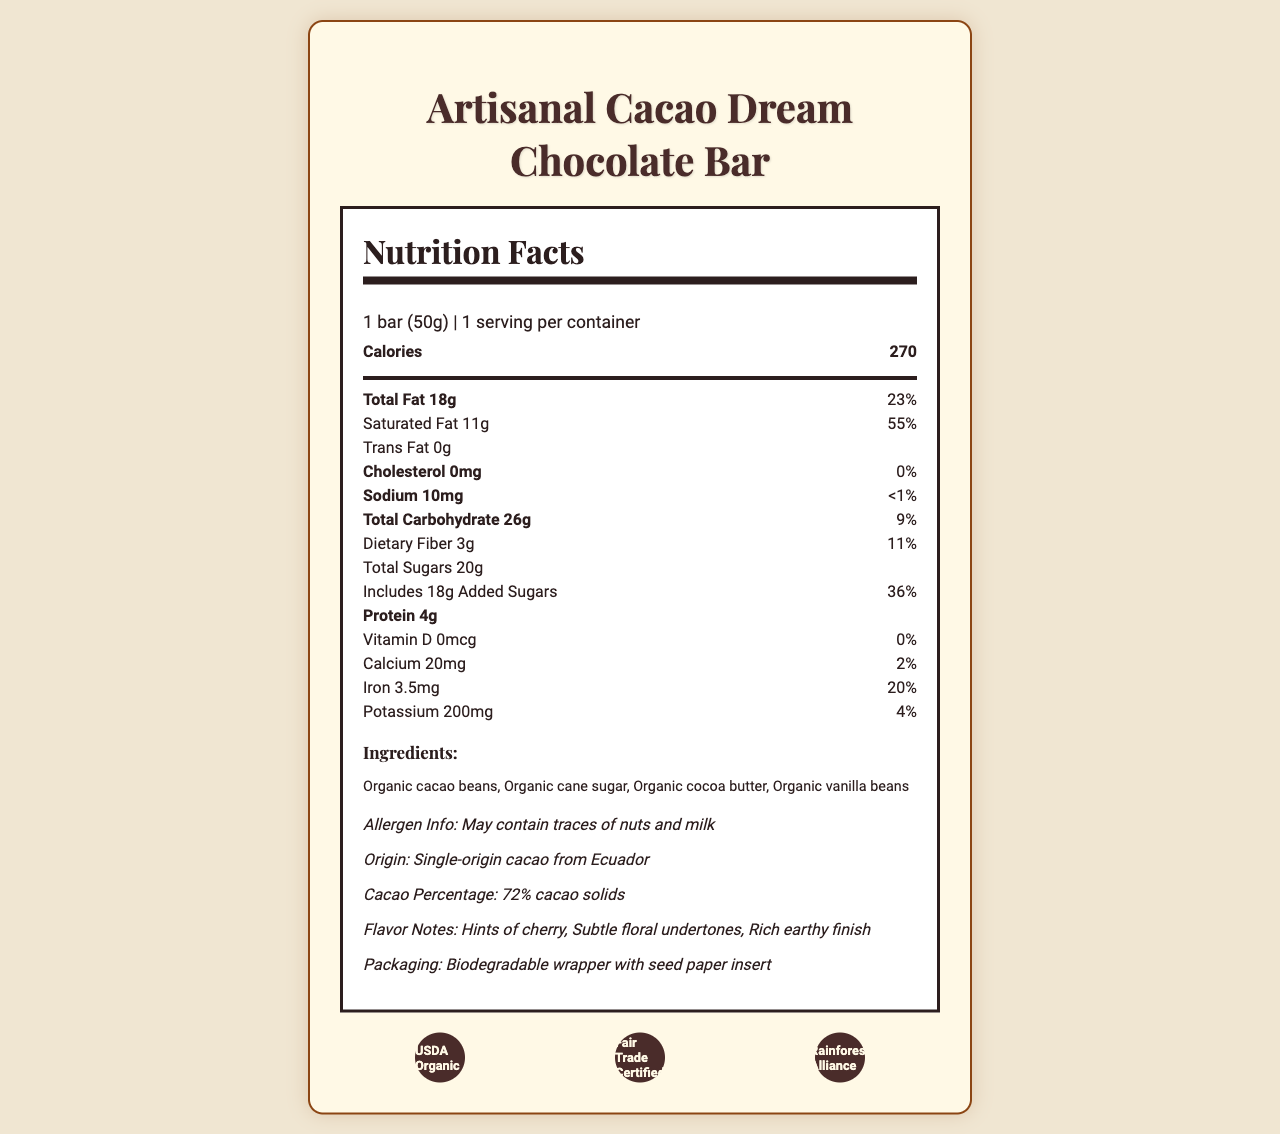what is the serving size of the Artisanal Cacao Dream Chocolate Bar? The serving size is explicitly mentioned as "1 bar (50g)" on the nutrition facts label.
Answer: 1 bar (50g) how many calories are in one serving? The document clearly states "Calories 270" under the nutrition details.
Answer: 270 list four key ingredients in the chocolate bar. The ingredients listed are: "Organic cacao beans, Organic cane sugar, Organic cocoa butter, Organic vanilla beans".
Answer: Organic cacao beans, Organic cane sugar, Organic cocoa butter, Organic vanilla beans what is the percentage of daily value for saturated fat? The document shows "Saturated Fat 11g 55%" in the nutritional facts.
Answer: 55% how much calcium does the chocolate bar contain? The amount of calcium is indicated as "Calcium 20mg" in the nutrition facts.
Answer: 20mg what certifications does the product have? The document lists the certifications as "USDA Organic, Fair Trade Certified, Rainforest Alliance".
Answer: USDA Organic, Fair Trade Certified, Rainforest Alliance what are the flavor notes of the chocolate bar? The flavor notes are given as "Hints of cherry, Subtle floral undertones, Rich earthy finish".
Answer: Hints of cherry, Subtle floral undertones, Rich earthy finish how much iron is in the chocolate bar and what is its daily value percentage? The document lists "Iron 3.5mg 20%" in the nutrition facts.
Answer: 3.5mg, 20% what is the total sugar content in the chocolate bar? The nutritional information states "Total Sugars 20g".
Answer: 20g for additional sweeter taste, how many grams of added sugars are included? Under the nutrition facts, "Includes 18g Added Sugars" is mentioned.
Answer: 18g how much protein does the chocolate bar have? The amount of protein is shown as "Protein 4g".
Answer: 4g which element is NOT included in the illustrations: A. Fermentation process sketch B. Roasting cacao beans illustration C. Harvesting cacao pods D. Conching machine sketch The illustration elements listed do not mention "Harvesting cacao pods".
Answer: C. Harvesting cacao pods how is the packaging of the Artisanal Cacao Dream Chocolate Bar described? A. Recyclable plastic wrapper B. Biodegradable wrapper with seed paper insert C. Metal foil wrapper D. Compostable paper wrapper The document specifies "Biodegradable wrapper with seed paper insert" under packaging.
Answer: B. Biodegradable wrapper with seed paper insert does the chocolate bar contain any trans fat? The nutrition facts specify "Trans Fat 0g", indicating it contains no trans fat.
Answer: No is the chocolate bar suitable for someone with a nut allergy? The allergen info states "May contain traces of nuts and milk", indicating it might not be suitable for someone with a nut allergy.
Answer: No how is the artistic style of the illustrations described? The document describes various artistic features: "Hand-drawn botanical style illustrations, Delicate line work, Subtle shading techniques, Vintage-inspired typography, Ornate frame around nutrition label".
Answer: Hand-drawn botanical style illustrations, Delicate line work, Subtle shading techniques, Vintage-inspired typography, Ornate frame around nutrition label briefly describe the important details provided in this document. The document includes nutritional details such as calories, fats, sugars, and protein; lists ingredients and potential allergens; highlights certifications; describes flavor notes and packaging details, and provides information about the artistic illustrations on the label.
Answer: This document contains detailed information about the Artisanal Cacao Dream Chocolate Bar, including its nutritional facts, ingredients, allergen warnings, certifications, flavor notes, packaging, and the artistic elements featured on its label. what is the origin of the cacao used in the chocolate bar? The origin is mentioned as "Single-origin cacao from Ecuador" in the document.
Answer: Single-origin cacao from Ecuador how many certifications does the Artisanal Cacao Dream Chocolate Bar have? The document lists three certifications: USDA Organic, Fair Trade Certified, and Rainforest Alliance.
Answer: 3 what is the detailed process for crafting the illustrations on the label? The document does not provide specific details on the process used to create the hand-drawn illustrations; it only describes the style and elements of the artwork.
Answer: Cannot be determined 